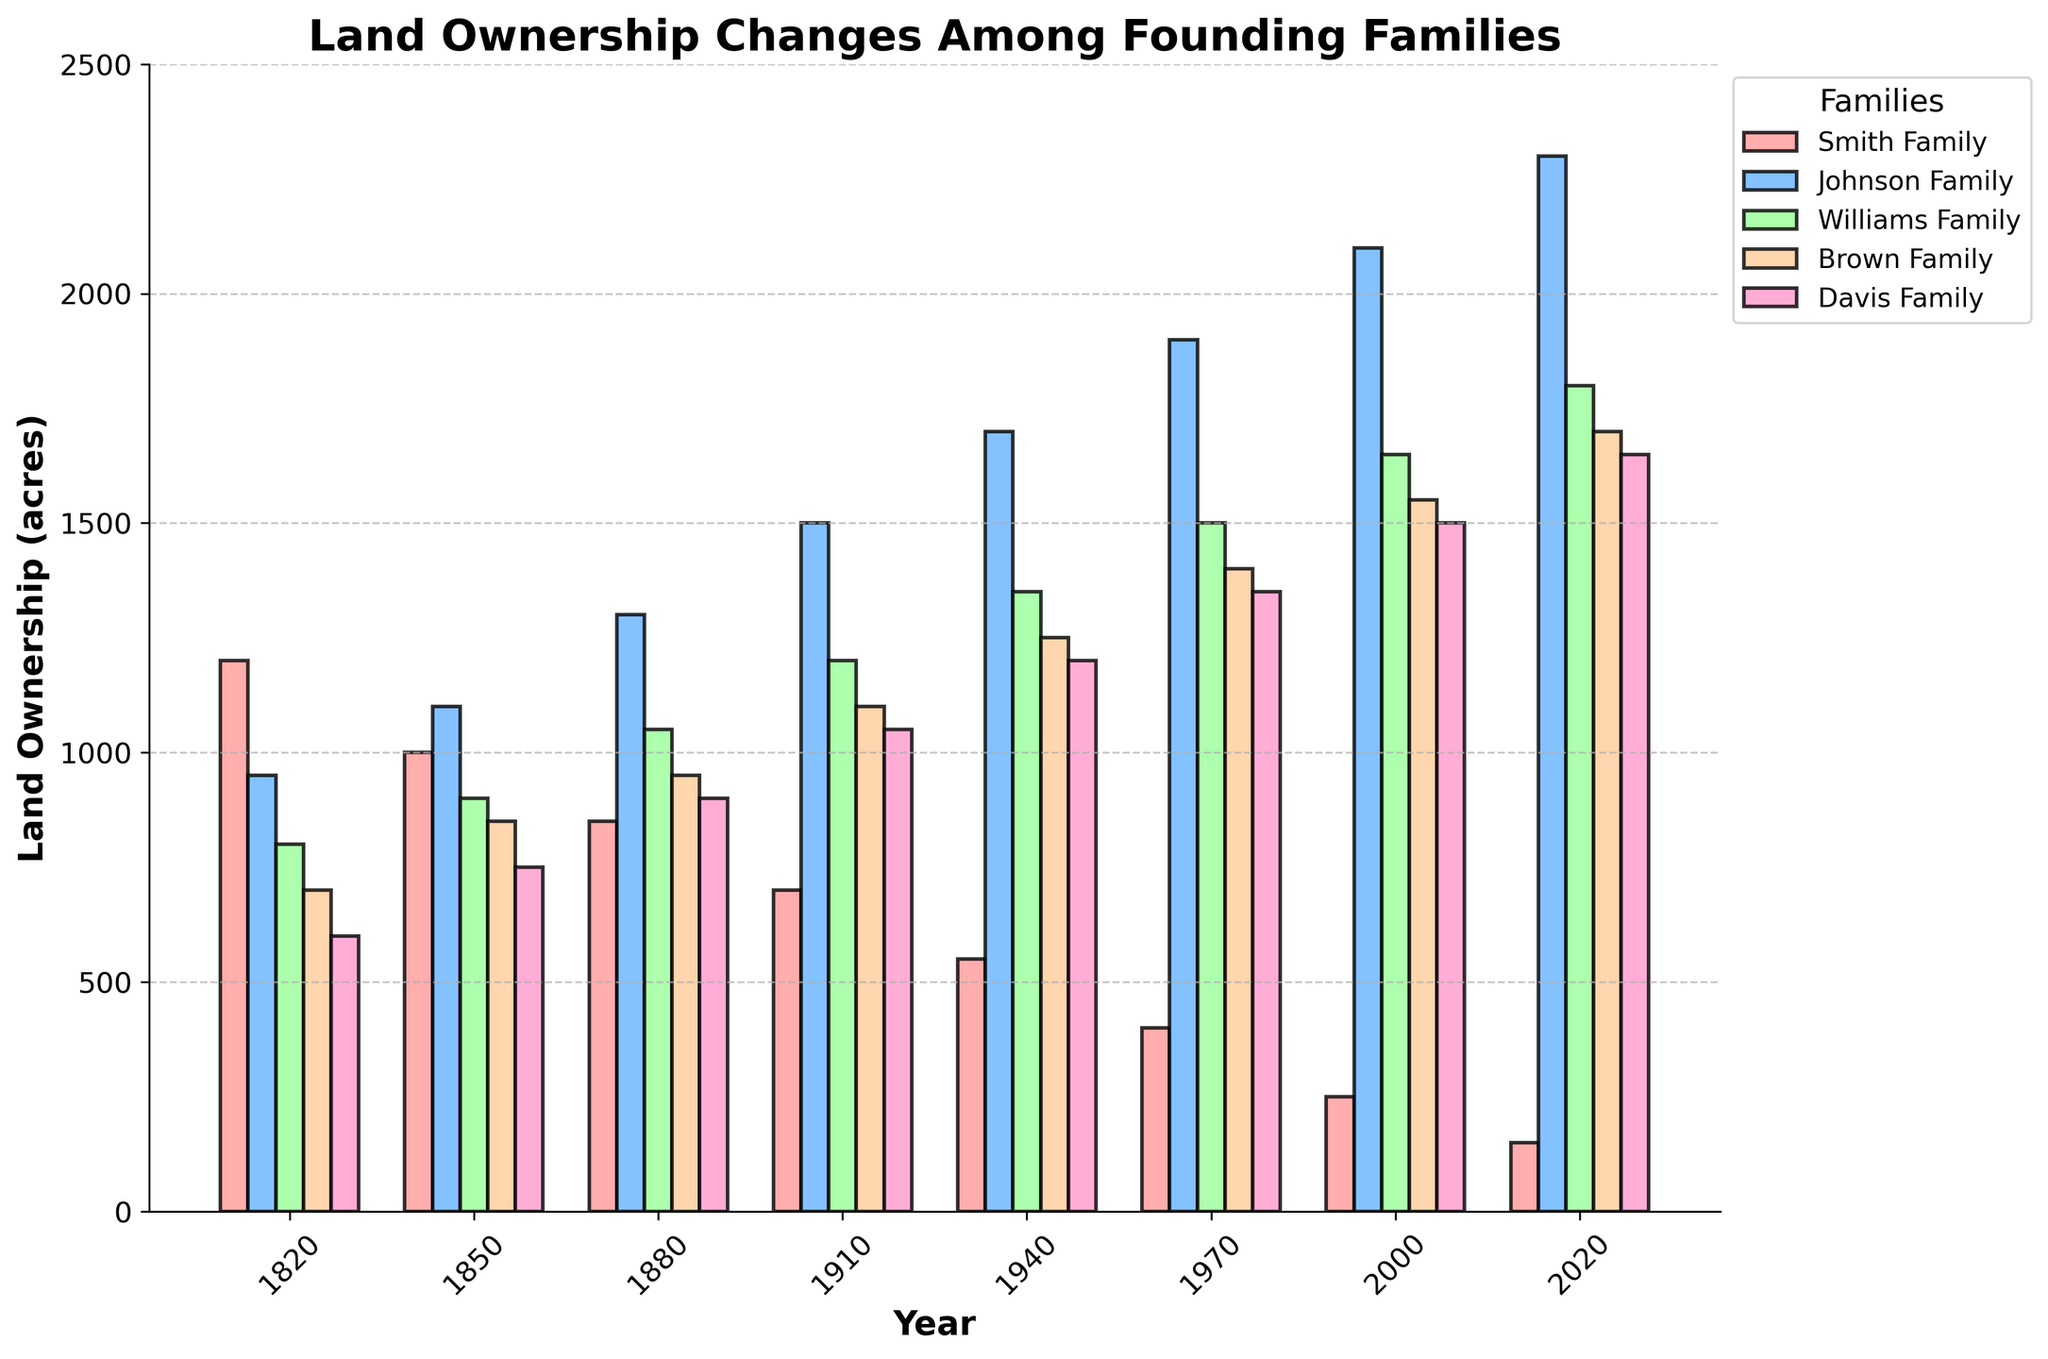What is the total land ownership of the Johnson Family across all years? Sum the land ownership of the Johnson Family for each year: 950 + 1100 + 1300 + 1500 + 1700 + 1900 + 2100 + 2300 = 12850
Answer: 12850 acres Which family had the largest decline in land ownership from 1820 to 2020? Compare the land values from 1820 to 2020 for each family: Smith (1200 to 150 = -1050), Johnson (950 to 2300 = +1350), Williams (800 to 1800 = +1000), Brown (700 to 1700 = +1000), Davis (600 to 1650 = +1050). The Smith Family had the largest decline.
Answer: Smith Family In which year did the Smith Family first have less than 1000 acres of land? Check the values for the Smith Family for each year and find the first year with fewer than 1000 acres: 1820 (1200), 1850 (1000), 1880 (850). The first year is 1880.
Answer: 1880 How many times did the Johnson Family have the most land ownership compared to other families? Identify the years where the Johnson Family had the highest value: 1850, 1880, 1910, 1940, 1970, 2000, 2020 (a total of 7 times).
Answer: 7 Which family showed a continuous increase in their land ownership from 1820 to 2020? Look at the trend for each family across all years: Smith (decreasing), Johnson (increasing), Williams (increasing), Brown (increasing), Davis (increasing). The Johnson, Williams, Brown, and Davis Families showed continuous increases.
Answer: Johnson, Williams, Brown, Davis Families By how much did the land owned by the Davis Family increase from 1820 to 1940? Calculate the difference in land ownership for the Davis Family: 1940 (1200) - 1820 (600) = 600 acres.
Answer: 600 acres What was the total land ownership for all families in 1880? Sum the land ownership values for each family in 1880: 850(Smith) + 1300(Johnson) + 1050(Williams) + 950(Brown) + 900(Davis) = 5050 acres.
Answer: 5050 acres Which family held the second largest amount of land in 2000? Check the values for each family in 2000: Smith (250), Johnson (2100), Williams (1650), Brown (1550), Davis (1500). The second largest is the Williams Family with 1650 acres.
Answer: Williams Family 